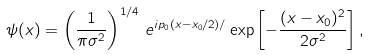<formula> <loc_0><loc_0><loc_500><loc_500>\psi ( x ) = \left ( \frac { 1 } { \pi \sigma ^ { 2 } } \right ) ^ { 1 / 4 } \, e ^ { i p _ { 0 } ( x - x _ { 0 } / 2 ) / } \exp \left [ - \frac { ( x - x _ { 0 } ) ^ { 2 } } { 2 \sigma ^ { 2 } } \right ] ,</formula> 